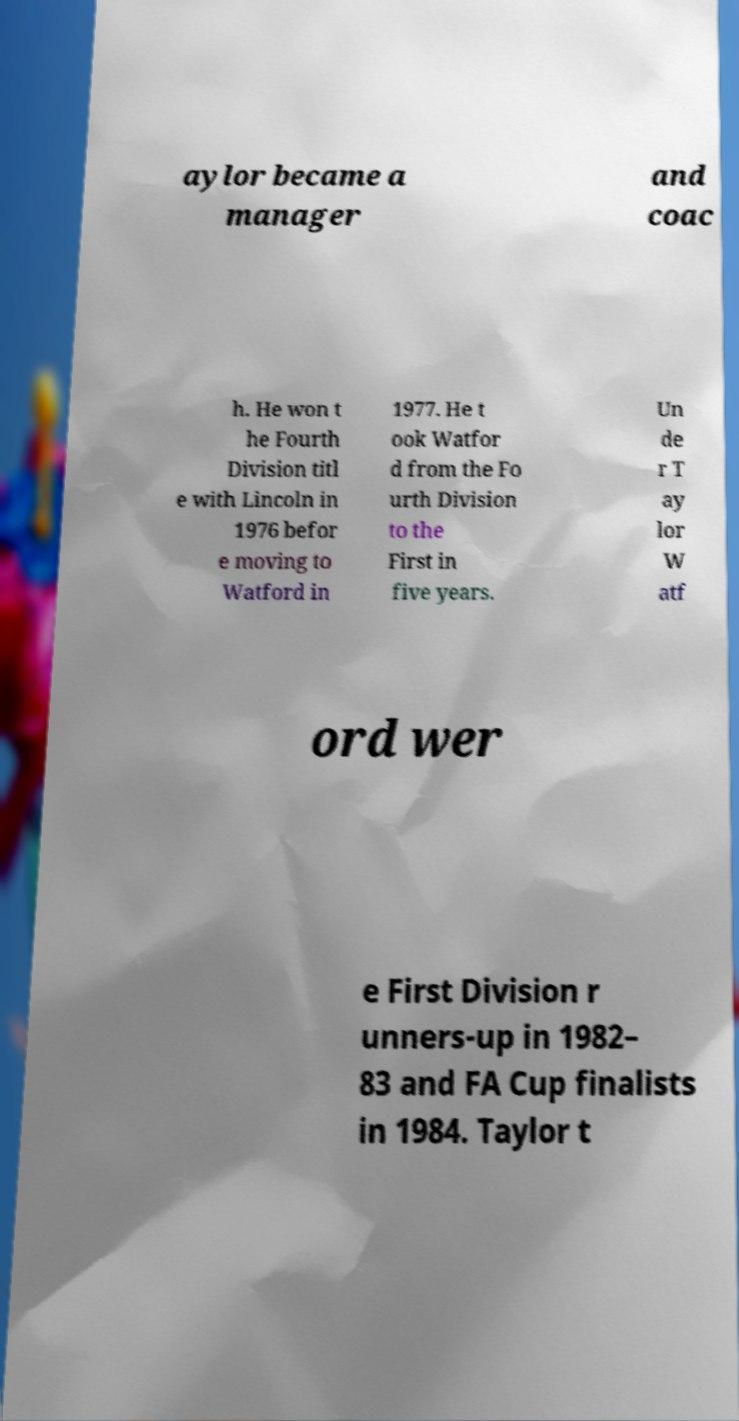For documentation purposes, I need the text within this image transcribed. Could you provide that? aylor became a manager and coac h. He won t he Fourth Division titl e with Lincoln in 1976 befor e moving to Watford in 1977. He t ook Watfor d from the Fo urth Division to the First in five years. Un de r T ay lor W atf ord wer e First Division r unners-up in 1982– 83 and FA Cup finalists in 1984. Taylor t 